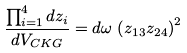Convert formula to latex. <formula><loc_0><loc_0><loc_500><loc_500>\frac { \prod _ { i = 1 } ^ { 4 } d z _ { i } } { d V _ { C K G } } = d \omega \, \left ( z _ { 1 3 } z _ { 2 4 } \right ) ^ { 2 }</formula> 